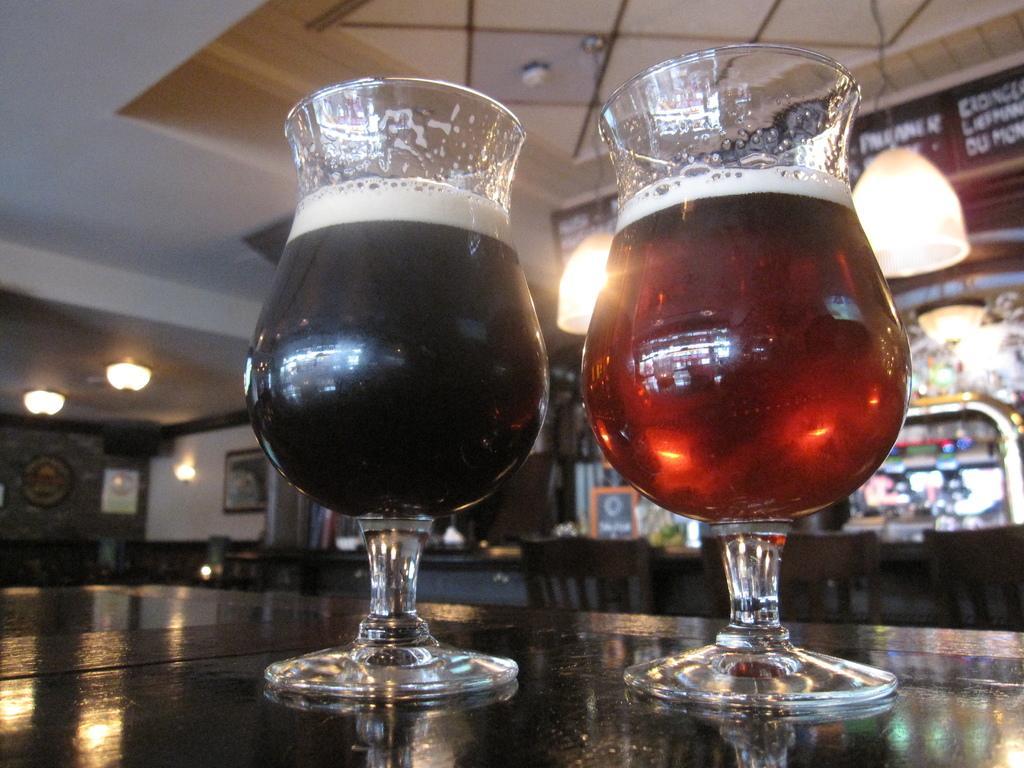Please provide a concise description of this image. In this image, we can see glasses on the table. There are lights hanging from the ceiling. There are other lights on the left side of the image. 